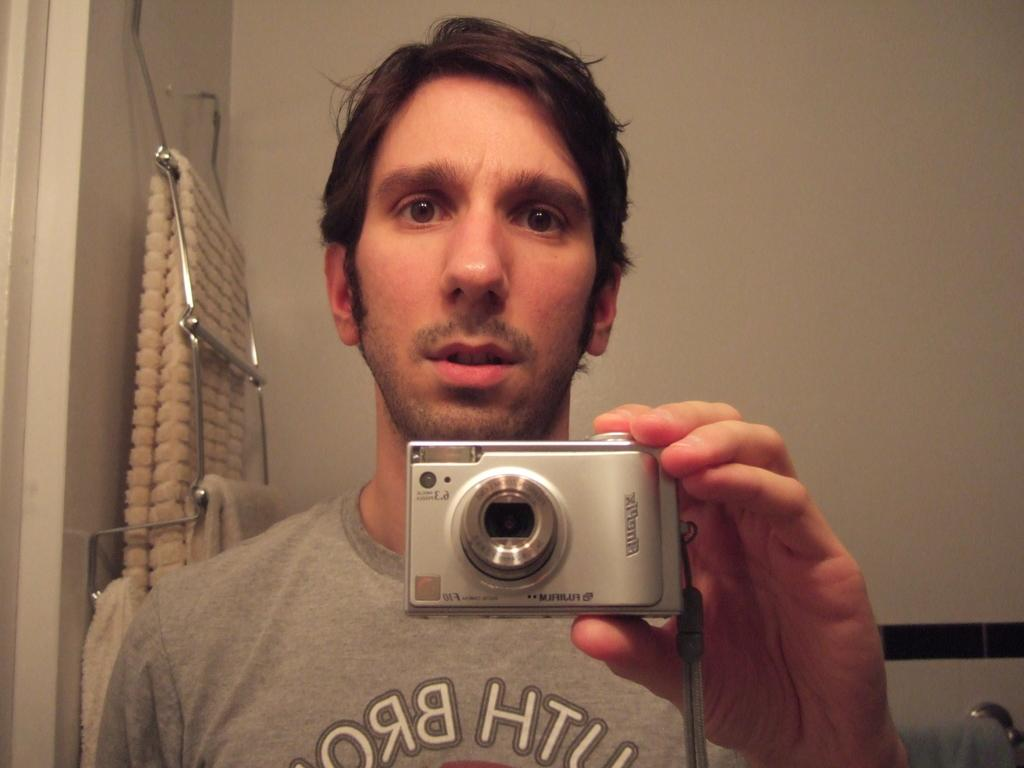What is present in the image? There is a person in the image. What is the person wearing? The person is wearing a T-shirt. What is the person holding in his hand? The person is holding a camera in his hand. What type of yard can be seen in the background of the image? There is no yard present in the image; it only shows a person wearing a T-shirt and holding a camera. 